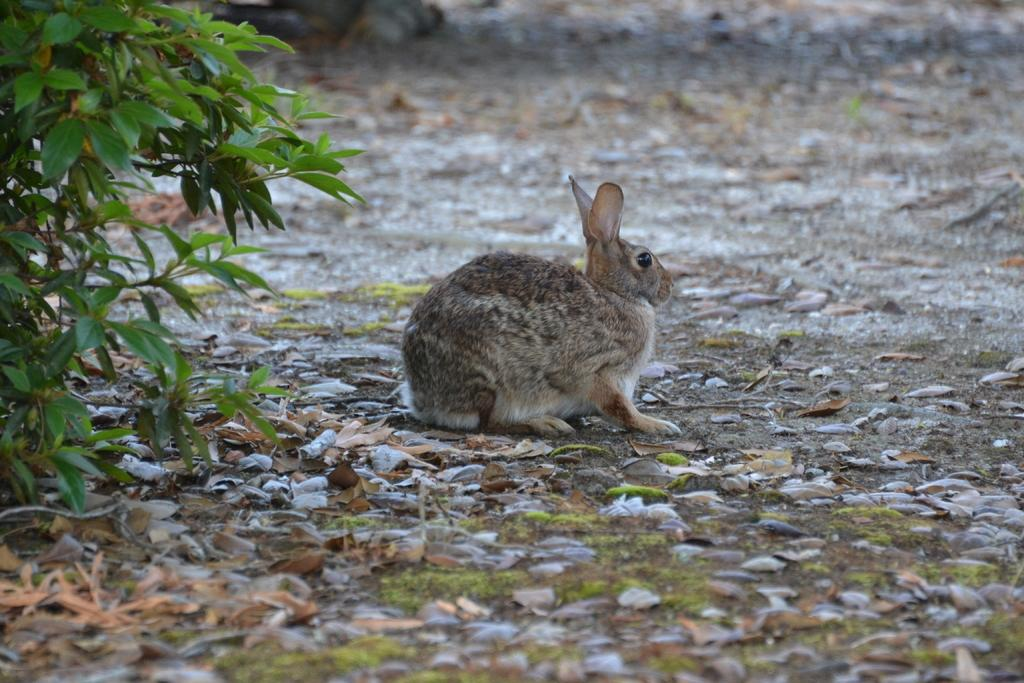What is the main subject in the center of the image? There is a rabbit in the center of the image. What can be seen on the left side of the image? There is a plant on the left side of the image. What type of vegetation is visible at the bottom of the image? There are leaves visible at the bottom of the image. How many women are present in the image? There are no women present in the image; it features a rabbit and a plant. What is the condition of the rabbit's knee in the image? There is no mention of the rabbit's knee in the image, and it is not possible to determine its condition. 